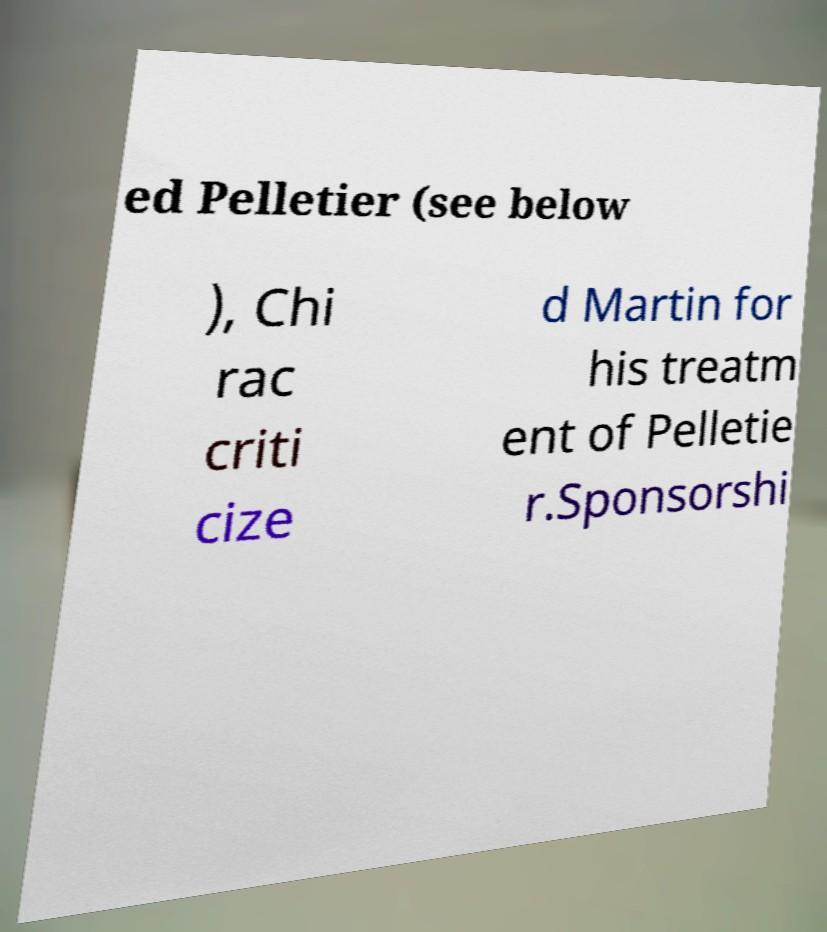Could you assist in decoding the text presented in this image and type it out clearly? ed Pelletier (see below ), Chi rac criti cize d Martin for his treatm ent of Pelletie r.Sponsorshi 